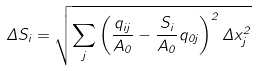Convert formula to latex. <formula><loc_0><loc_0><loc_500><loc_500>\Delta S _ { i } = \sqrt { \sum _ { j } \left ( \frac { q _ { i j } } { A _ { 0 } } - \frac { S _ { i } } { A _ { 0 } } q _ { 0 j } \right ) ^ { 2 } \Delta x _ { j } ^ { 2 } }</formula> 